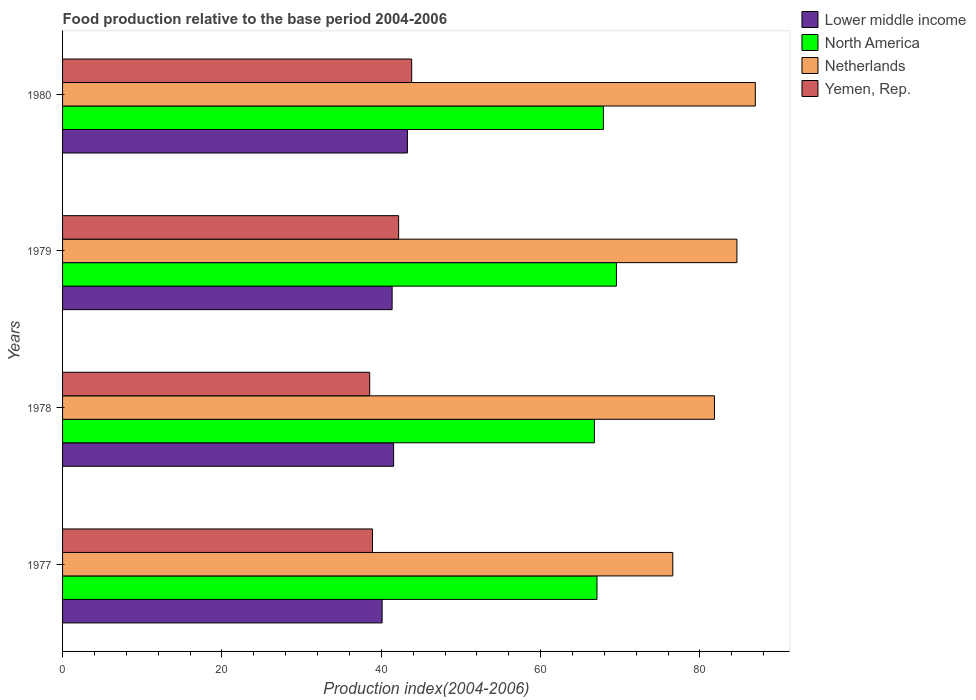What is the food production index in Lower middle income in 1977?
Your response must be concise. 40.11. Across all years, what is the maximum food production index in Netherlands?
Provide a short and direct response. 86.95. Across all years, what is the minimum food production index in Lower middle income?
Your answer should be very brief. 40.11. In which year was the food production index in Netherlands maximum?
Your response must be concise. 1980. In which year was the food production index in Yemen, Rep. minimum?
Provide a succinct answer. 1978. What is the total food production index in Yemen, Rep. in the graph?
Your answer should be very brief. 163.45. What is the difference between the food production index in Lower middle income in 1978 and that in 1980?
Give a very brief answer. -1.73. What is the difference between the food production index in Lower middle income in 1980 and the food production index in Netherlands in 1979?
Offer a very short reply. -41.36. What is the average food production index in Yemen, Rep. per year?
Provide a short and direct response. 40.86. In the year 1979, what is the difference between the food production index in Netherlands and food production index in North America?
Your answer should be compact. 15.12. In how many years, is the food production index in Netherlands greater than 12 ?
Keep it short and to the point. 4. What is the ratio of the food production index in North America in 1977 to that in 1978?
Your response must be concise. 1. Is the food production index in Yemen, Rep. in 1978 less than that in 1980?
Ensure brevity in your answer.  Yes. What is the difference between the highest and the second highest food production index in Netherlands?
Make the answer very short. 2.31. What is the difference between the highest and the lowest food production index in Yemen, Rep.?
Your response must be concise. 5.27. Is the sum of the food production index in North America in 1978 and 1980 greater than the maximum food production index in Netherlands across all years?
Make the answer very short. Yes. What does the 1st bar from the top in 1979 represents?
Your response must be concise. Yemen, Rep. What does the 2nd bar from the bottom in 1978 represents?
Your answer should be compact. North America. Are all the bars in the graph horizontal?
Give a very brief answer. Yes. Are the values on the major ticks of X-axis written in scientific E-notation?
Your response must be concise. No. Where does the legend appear in the graph?
Make the answer very short. Top right. What is the title of the graph?
Provide a short and direct response. Food production relative to the base period 2004-2006. What is the label or title of the X-axis?
Keep it short and to the point. Production index(2004-2006). What is the Production index(2004-2006) in Lower middle income in 1977?
Your answer should be compact. 40.11. What is the Production index(2004-2006) in North America in 1977?
Keep it short and to the point. 67.08. What is the Production index(2004-2006) in Netherlands in 1977?
Give a very brief answer. 76.59. What is the Production index(2004-2006) in Yemen, Rep. in 1977?
Ensure brevity in your answer.  38.9. What is the Production index(2004-2006) of Lower middle income in 1978?
Provide a succinct answer. 41.55. What is the Production index(2004-2006) of North America in 1978?
Ensure brevity in your answer.  66.75. What is the Production index(2004-2006) in Netherlands in 1978?
Offer a terse response. 81.82. What is the Production index(2004-2006) of Yemen, Rep. in 1978?
Give a very brief answer. 38.55. What is the Production index(2004-2006) of Lower middle income in 1979?
Your answer should be compact. 41.36. What is the Production index(2004-2006) of North America in 1979?
Give a very brief answer. 69.52. What is the Production index(2004-2006) of Netherlands in 1979?
Offer a terse response. 84.64. What is the Production index(2004-2006) in Yemen, Rep. in 1979?
Keep it short and to the point. 42.18. What is the Production index(2004-2006) of Lower middle income in 1980?
Your answer should be compact. 43.28. What is the Production index(2004-2006) in North America in 1980?
Ensure brevity in your answer.  67.88. What is the Production index(2004-2006) in Netherlands in 1980?
Offer a very short reply. 86.95. What is the Production index(2004-2006) of Yemen, Rep. in 1980?
Offer a very short reply. 43.82. Across all years, what is the maximum Production index(2004-2006) in Lower middle income?
Ensure brevity in your answer.  43.28. Across all years, what is the maximum Production index(2004-2006) in North America?
Keep it short and to the point. 69.52. Across all years, what is the maximum Production index(2004-2006) of Netherlands?
Ensure brevity in your answer.  86.95. Across all years, what is the maximum Production index(2004-2006) of Yemen, Rep.?
Make the answer very short. 43.82. Across all years, what is the minimum Production index(2004-2006) of Lower middle income?
Provide a short and direct response. 40.11. Across all years, what is the minimum Production index(2004-2006) of North America?
Offer a very short reply. 66.75. Across all years, what is the minimum Production index(2004-2006) in Netherlands?
Keep it short and to the point. 76.59. Across all years, what is the minimum Production index(2004-2006) in Yemen, Rep.?
Your answer should be very brief. 38.55. What is the total Production index(2004-2006) in Lower middle income in the graph?
Offer a terse response. 166.3. What is the total Production index(2004-2006) of North America in the graph?
Offer a terse response. 271.22. What is the total Production index(2004-2006) in Netherlands in the graph?
Provide a short and direct response. 330. What is the total Production index(2004-2006) of Yemen, Rep. in the graph?
Offer a terse response. 163.45. What is the difference between the Production index(2004-2006) of Lower middle income in 1977 and that in 1978?
Your answer should be very brief. -1.44. What is the difference between the Production index(2004-2006) in North America in 1977 and that in 1978?
Offer a terse response. 0.32. What is the difference between the Production index(2004-2006) in Netherlands in 1977 and that in 1978?
Offer a terse response. -5.23. What is the difference between the Production index(2004-2006) in Lower middle income in 1977 and that in 1979?
Provide a short and direct response. -1.26. What is the difference between the Production index(2004-2006) in North America in 1977 and that in 1979?
Your response must be concise. -2.44. What is the difference between the Production index(2004-2006) in Netherlands in 1977 and that in 1979?
Your answer should be very brief. -8.05. What is the difference between the Production index(2004-2006) of Yemen, Rep. in 1977 and that in 1979?
Your response must be concise. -3.28. What is the difference between the Production index(2004-2006) in Lower middle income in 1977 and that in 1980?
Your response must be concise. -3.18. What is the difference between the Production index(2004-2006) of North America in 1977 and that in 1980?
Keep it short and to the point. -0.8. What is the difference between the Production index(2004-2006) of Netherlands in 1977 and that in 1980?
Provide a short and direct response. -10.36. What is the difference between the Production index(2004-2006) of Yemen, Rep. in 1977 and that in 1980?
Your answer should be compact. -4.92. What is the difference between the Production index(2004-2006) of Lower middle income in 1978 and that in 1979?
Ensure brevity in your answer.  0.19. What is the difference between the Production index(2004-2006) of North America in 1978 and that in 1979?
Provide a short and direct response. -2.76. What is the difference between the Production index(2004-2006) in Netherlands in 1978 and that in 1979?
Your response must be concise. -2.82. What is the difference between the Production index(2004-2006) of Yemen, Rep. in 1978 and that in 1979?
Keep it short and to the point. -3.63. What is the difference between the Production index(2004-2006) in Lower middle income in 1978 and that in 1980?
Provide a short and direct response. -1.73. What is the difference between the Production index(2004-2006) in North America in 1978 and that in 1980?
Your answer should be compact. -1.13. What is the difference between the Production index(2004-2006) of Netherlands in 1978 and that in 1980?
Your response must be concise. -5.13. What is the difference between the Production index(2004-2006) of Yemen, Rep. in 1978 and that in 1980?
Your answer should be very brief. -5.27. What is the difference between the Production index(2004-2006) of Lower middle income in 1979 and that in 1980?
Provide a short and direct response. -1.92. What is the difference between the Production index(2004-2006) in North America in 1979 and that in 1980?
Offer a terse response. 1.64. What is the difference between the Production index(2004-2006) of Netherlands in 1979 and that in 1980?
Provide a short and direct response. -2.31. What is the difference between the Production index(2004-2006) of Yemen, Rep. in 1979 and that in 1980?
Offer a terse response. -1.64. What is the difference between the Production index(2004-2006) of Lower middle income in 1977 and the Production index(2004-2006) of North America in 1978?
Offer a terse response. -26.65. What is the difference between the Production index(2004-2006) in Lower middle income in 1977 and the Production index(2004-2006) in Netherlands in 1978?
Your answer should be compact. -41.71. What is the difference between the Production index(2004-2006) of Lower middle income in 1977 and the Production index(2004-2006) of Yemen, Rep. in 1978?
Provide a short and direct response. 1.56. What is the difference between the Production index(2004-2006) in North America in 1977 and the Production index(2004-2006) in Netherlands in 1978?
Offer a terse response. -14.74. What is the difference between the Production index(2004-2006) of North America in 1977 and the Production index(2004-2006) of Yemen, Rep. in 1978?
Your answer should be very brief. 28.53. What is the difference between the Production index(2004-2006) in Netherlands in 1977 and the Production index(2004-2006) in Yemen, Rep. in 1978?
Keep it short and to the point. 38.04. What is the difference between the Production index(2004-2006) of Lower middle income in 1977 and the Production index(2004-2006) of North America in 1979?
Your answer should be compact. -29.41. What is the difference between the Production index(2004-2006) of Lower middle income in 1977 and the Production index(2004-2006) of Netherlands in 1979?
Offer a terse response. -44.53. What is the difference between the Production index(2004-2006) of Lower middle income in 1977 and the Production index(2004-2006) of Yemen, Rep. in 1979?
Ensure brevity in your answer.  -2.07. What is the difference between the Production index(2004-2006) of North America in 1977 and the Production index(2004-2006) of Netherlands in 1979?
Ensure brevity in your answer.  -17.56. What is the difference between the Production index(2004-2006) of North America in 1977 and the Production index(2004-2006) of Yemen, Rep. in 1979?
Provide a short and direct response. 24.9. What is the difference between the Production index(2004-2006) in Netherlands in 1977 and the Production index(2004-2006) in Yemen, Rep. in 1979?
Keep it short and to the point. 34.41. What is the difference between the Production index(2004-2006) of Lower middle income in 1977 and the Production index(2004-2006) of North America in 1980?
Your answer should be very brief. -27.77. What is the difference between the Production index(2004-2006) in Lower middle income in 1977 and the Production index(2004-2006) in Netherlands in 1980?
Provide a short and direct response. -46.84. What is the difference between the Production index(2004-2006) in Lower middle income in 1977 and the Production index(2004-2006) in Yemen, Rep. in 1980?
Provide a short and direct response. -3.71. What is the difference between the Production index(2004-2006) of North America in 1977 and the Production index(2004-2006) of Netherlands in 1980?
Your response must be concise. -19.87. What is the difference between the Production index(2004-2006) of North America in 1977 and the Production index(2004-2006) of Yemen, Rep. in 1980?
Your answer should be compact. 23.26. What is the difference between the Production index(2004-2006) of Netherlands in 1977 and the Production index(2004-2006) of Yemen, Rep. in 1980?
Offer a very short reply. 32.77. What is the difference between the Production index(2004-2006) of Lower middle income in 1978 and the Production index(2004-2006) of North America in 1979?
Ensure brevity in your answer.  -27.97. What is the difference between the Production index(2004-2006) in Lower middle income in 1978 and the Production index(2004-2006) in Netherlands in 1979?
Keep it short and to the point. -43.09. What is the difference between the Production index(2004-2006) in Lower middle income in 1978 and the Production index(2004-2006) in Yemen, Rep. in 1979?
Your answer should be compact. -0.63. What is the difference between the Production index(2004-2006) of North America in 1978 and the Production index(2004-2006) of Netherlands in 1979?
Provide a succinct answer. -17.89. What is the difference between the Production index(2004-2006) in North America in 1978 and the Production index(2004-2006) in Yemen, Rep. in 1979?
Provide a succinct answer. 24.57. What is the difference between the Production index(2004-2006) of Netherlands in 1978 and the Production index(2004-2006) of Yemen, Rep. in 1979?
Your answer should be very brief. 39.64. What is the difference between the Production index(2004-2006) in Lower middle income in 1978 and the Production index(2004-2006) in North America in 1980?
Your answer should be very brief. -26.33. What is the difference between the Production index(2004-2006) of Lower middle income in 1978 and the Production index(2004-2006) of Netherlands in 1980?
Make the answer very short. -45.4. What is the difference between the Production index(2004-2006) of Lower middle income in 1978 and the Production index(2004-2006) of Yemen, Rep. in 1980?
Offer a very short reply. -2.27. What is the difference between the Production index(2004-2006) in North America in 1978 and the Production index(2004-2006) in Netherlands in 1980?
Keep it short and to the point. -20.2. What is the difference between the Production index(2004-2006) in North America in 1978 and the Production index(2004-2006) in Yemen, Rep. in 1980?
Give a very brief answer. 22.93. What is the difference between the Production index(2004-2006) of Lower middle income in 1979 and the Production index(2004-2006) of North America in 1980?
Offer a very short reply. -26.52. What is the difference between the Production index(2004-2006) of Lower middle income in 1979 and the Production index(2004-2006) of Netherlands in 1980?
Provide a short and direct response. -45.59. What is the difference between the Production index(2004-2006) of Lower middle income in 1979 and the Production index(2004-2006) of Yemen, Rep. in 1980?
Your response must be concise. -2.46. What is the difference between the Production index(2004-2006) in North America in 1979 and the Production index(2004-2006) in Netherlands in 1980?
Offer a very short reply. -17.43. What is the difference between the Production index(2004-2006) in North America in 1979 and the Production index(2004-2006) in Yemen, Rep. in 1980?
Your response must be concise. 25.7. What is the difference between the Production index(2004-2006) of Netherlands in 1979 and the Production index(2004-2006) of Yemen, Rep. in 1980?
Offer a terse response. 40.82. What is the average Production index(2004-2006) of Lower middle income per year?
Provide a short and direct response. 41.58. What is the average Production index(2004-2006) in North America per year?
Offer a terse response. 67.81. What is the average Production index(2004-2006) of Netherlands per year?
Your answer should be compact. 82.5. What is the average Production index(2004-2006) in Yemen, Rep. per year?
Ensure brevity in your answer.  40.86. In the year 1977, what is the difference between the Production index(2004-2006) in Lower middle income and Production index(2004-2006) in North America?
Ensure brevity in your answer.  -26.97. In the year 1977, what is the difference between the Production index(2004-2006) in Lower middle income and Production index(2004-2006) in Netherlands?
Your answer should be very brief. -36.48. In the year 1977, what is the difference between the Production index(2004-2006) of Lower middle income and Production index(2004-2006) of Yemen, Rep.?
Provide a succinct answer. 1.21. In the year 1977, what is the difference between the Production index(2004-2006) of North America and Production index(2004-2006) of Netherlands?
Offer a terse response. -9.51. In the year 1977, what is the difference between the Production index(2004-2006) of North America and Production index(2004-2006) of Yemen, Rep.?
Make the answer very short. 28.18. In the year 1977, what is the difference between the Production index(2004-2006) in Netherlands and Production index(2004-2006) in Yemen, Rep.?
Keep it short and to the point. 37.69. In the year 1978, what is the difference between the Production index(2004-2006) in Lower middle income and Production index(2004-2006) in North America?
Ensure brevity in your answer.  -25.2. In the year 1978, what is the difference between the Production index(2004-2006) in Lower middle income and Production index(2004-2006) in Netherlands?
Make the answer very short. -40.27. In the year 1978, what is the difference between the Production index(2004-2006) in Lower middle income and Production index(2004-2006) in Yemen, Rep.?
Your answer should be compact. 3. In the year 1978, what is the difference between the Production index(2004-2006) of North America and Production index(2004-2006) of Netherlands?
Offer a terse response. -15.07. In the year 1978, what is the difference between the Production index(2004-2006) of North America and Production index(2004-2006) of Yemen, Rep.?
Your answer should be very brief. 28.2. In the year 1978, what is the difference between the Production index(2004-2006) in Netherlands and Production index(2004-2006) in Yemen, Rep.?
Offer a very short reply. 43.27. In the year 1979, what is the difference between the Production index(2004-2006) of Lower middle income and Production index(2004-2006) of North America?
Ensure brevity in your answer.  -28.15. In the year 1979, what is the difference between the Production index(2004-2006) of Lower middle income and Production index(2004-2006) of Netherlands?
Your answer should be very brief. -43.28. In the year 1979, what is the difference between the Production index(2004-2006) of Lower middle income and Production index(2004-2006) of Yemen, Rep.?
Keep it short and to the point. -0.82. In the year 1979, what is the difference between the Production index(2004-2006) in North America and Production index(2004-2006) in Netherlands?
Offer a terse response. -15.12. In the year 1979, what is the difference between the Production index(2004-2006) of North America and Production index(2004-2006) of Yemen, Rep.?
Make the answer very short. 27.34. In the year 1979, what is the difference between the Production index(2004-2006) of Netherlands and Production index(2004-2006) of Yemen, Rep.?
Offer a very short reply. 42.46. In the year 1980, what is the difference between the Production index(2004-2006) in Lower middle income and Production index(2004-2006) in North America?
Keep it short and to the point. -24.6. In the year 1980, what is the difference between the Production index(2004-2006) in Lower middle income and Production index(2004-2006) in Netherlands?
Provide a short and direct response. -43.67. In the year 1980, what is the difference between the Production index(2004-2006) of Lower middle income and Production index(2004-2006) of Yemen, Rep.?
Ensure brevity in your answer.  -0.54. In the year 1980, what is the difference between the Production index(2004-2006) of North America and Production index(2004-2006) of Netherlands?
Provide a short and direct response. -19.07. In the year 1980, what is the difference between the Production index(2004-2006) of North America and Production index(2004-2006) of Yemen, Rep.?
Keep it short and to the point. 24.06. In the year 1980, what is the difference between the Production index(2004-2006) in Netherlands and Production index(2004-2006) in Yemen, Rep.?
Make the answer very short. 43.13. What is the ratio of the Production index(2004-2006) of Lower middle income in 1977 to that in 1978?
Provide a short and direct response. 0.97. What is the ratio of the Production index(2004-2006) in Netherlands in 1977 to that in 1978?
Keep it short and to the point. 0.94. What is the ratio of the Production index(2004-2006) of Yemen, Rep. in 1977 to that in 1978?
Offer a terse response. 1.01. What is the ratio of the Production index(2004-2006) of Lower middle income in 1977 to that in 1979?
Make the answer very short. 0.97. What is the ratio of the Production index(2004-2006) in North America in 1977 to that in 1979?
Offer a very short reply. 0.96. What is the ratio of the Production index(2004-2006) in Netherlands in 1977 to that in 1979?
Ensure brevity in your answer.  0.9. What is the ratio of the Production index(2004-2006) in Yemen, Rep. in 1977 to that in 1979?
Your answer should be very brief. 0.92. What is the ratio of the Production index(2004-2006) of Lower middle income in 1977 to that in 1980?
Your answer should be very brief. 0.93. What is the ratio of the Production index(2004-2006) of Netherlands in 1977 to that in 1980?
Your response must be concise. 0.88. What is the ratio of the Production index(2004-2006) in Yemen, Rep. in 1977 to that in 1980?
Offer a very short reply. 0.89. What is the ratio of the Production index(2004-2006) of North America in 1978 to that in 1979?
Offer a terse response. 0.96. What is the ratio of the Production index(2004-2006) in Netherlands in 1978 to that in 1979?
Your answer should be compact. 0.97. What is the ratio of the Production index(2004-2006) of Yemen, Rep. in 1978 to that in 1979?
Provide a succinct answer. 0.91. What is the ratio of the Production index(2004-2006) of North America in 1978 to that in 1980?
Offer a very short reply. 0.98. What is the ratio of the Production index(2004-2006) of Netherlands in 1978 to that in 1980?
Ensure brevity in your answer.  0.94. What is the ratio of the Production index(2004-2006) of Yemen, Rep. in 1978 to that in 1980?
Give a very brief answer. 0.88. What is the ratio of the Production index(2004-2006) in Lower middle income in 1979 to that in 1980?
Your answer should be very brief. 0.96. What is the ratio of the Production index(2004-2006) of North America in 1979 to that in 1980?
Make the answer very short. 1.02. What is the ratio of the Production index(2004-2006) of Netherlands in 1979 to that in 1980?
Offer a terse response. 0.97. What is the ratio of the Production index(2004-2006) in Yemen, Rep. in 1979 to that in 1980?
Keep it short and to the point. 0.96. What is the difference between the highest and the second highest Production index(2004-2006) of Lower middle income?
Your answer should be very brief. 1.73. What is the difference between the highest and the second highest Production index(2004-2006) in North America?
Give a very brief answer. 1.64. What is the difference between the highest and the second highest Production index(2004-2006) in Netherlands?
Keep it short and to the point. 2.31. What is the difference between the highest and the second highest Production index(2004-2006) of Yemen, Rep.?
Give a very brief answer. 1.64. What is the difference between the highest and the lowest Production index(2004-2006) in Lower middle income?
Your response must be concise. 3.18. What is the difference between the highest and the lowest Production index(2004-2006) of North America?
Keep it short and to the point. 2.76. What is the difference between the highest and the lowest Production index(2004-2006) in Netherlands?
Your response must be concise. 10.36. What is the difference between the highest and the lowest Production index(2004-2006) in Yemen, Rep.?
Offer a terse response. 5.27. 